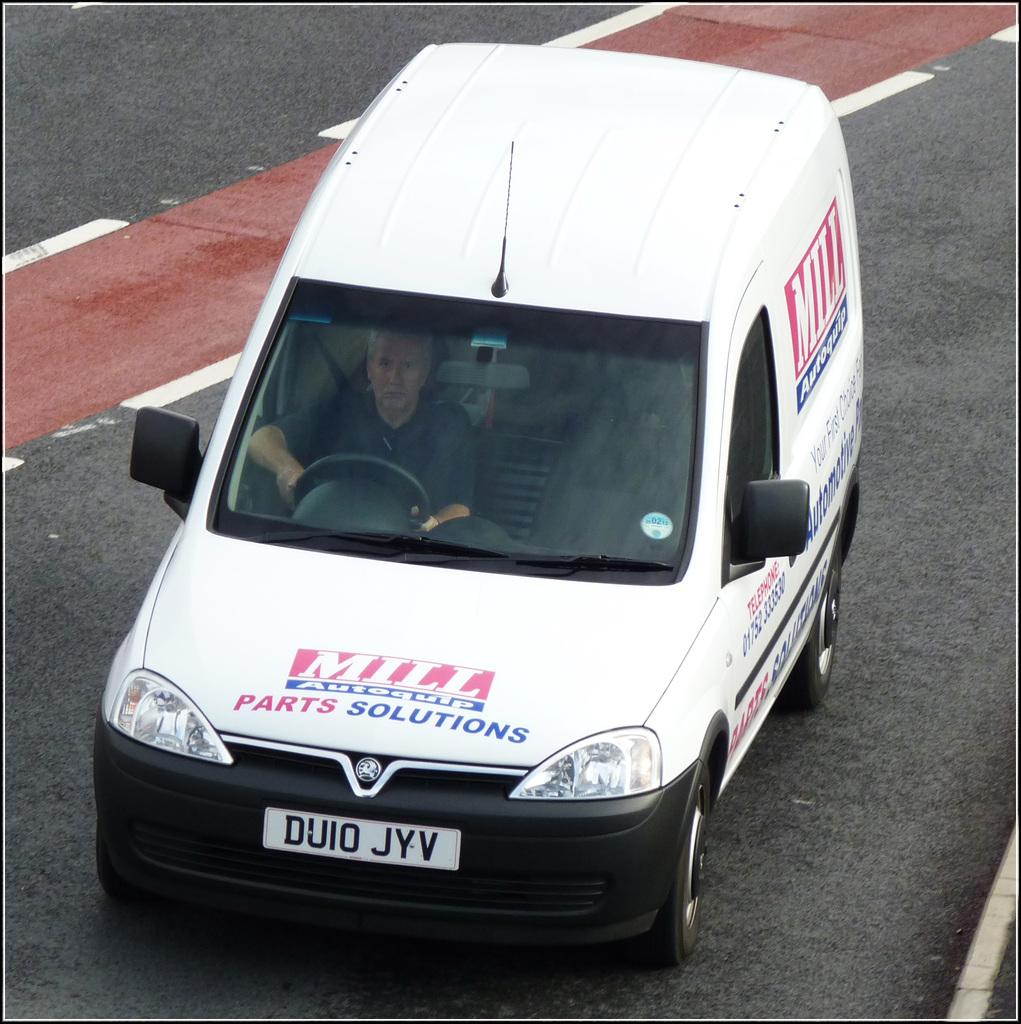What is the person in the image doing? There is a person sitting inside a vehicle in the image. What can be seen on the vehicle? The vehicle has a number plate and some text. Where is the vehicle located? The vehicle is parked on the road. What type of ring can be seen on the vehicle's windshield in the image? There is no ring visible on the vehicle's windshield in the image. 